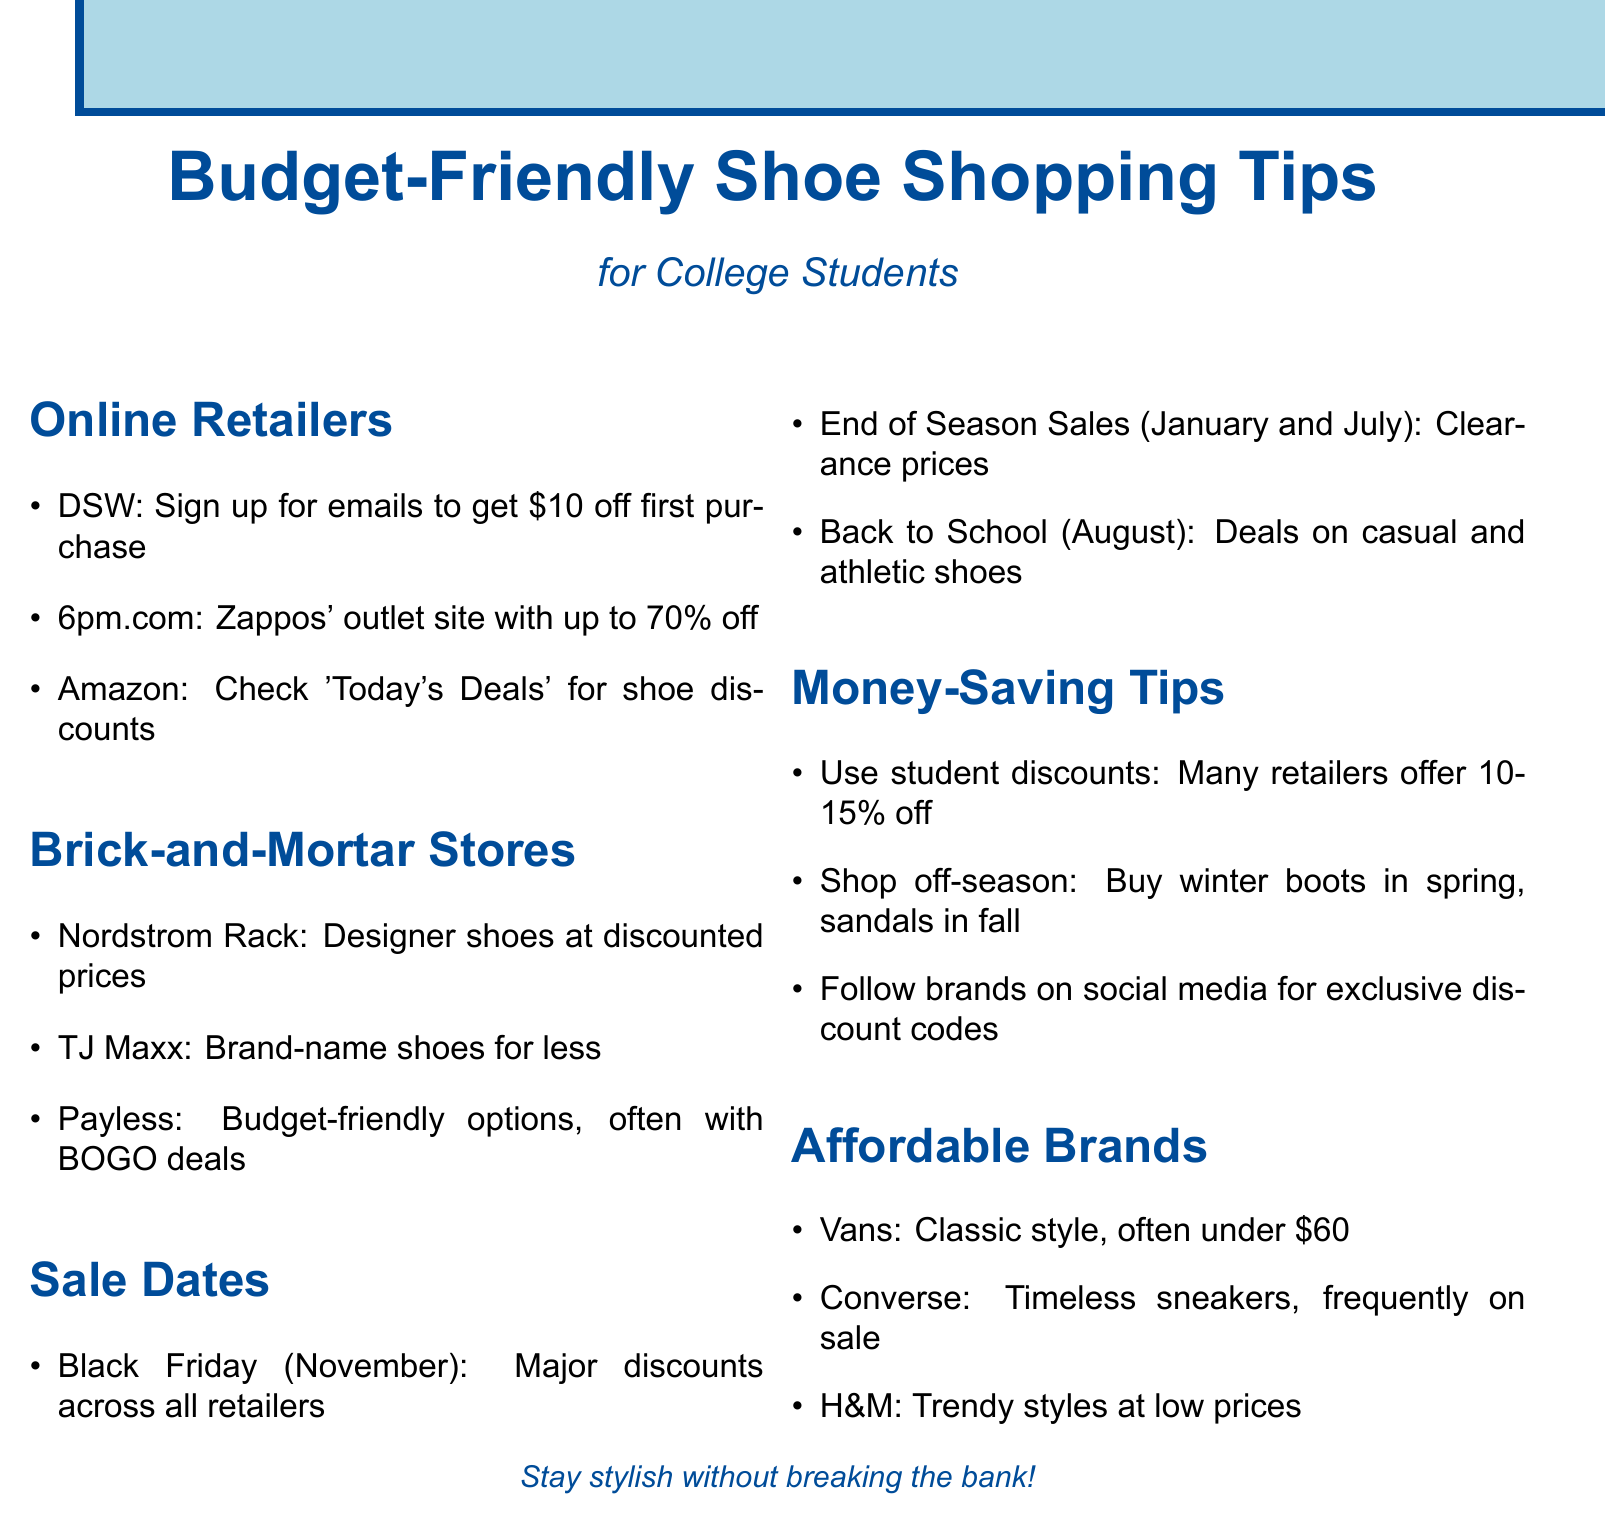What is the title of the document? The title of the document is stated at the top and summarizes the content.
Answer: Budget-Friendly Shoe Shopping Tips for College Students Which retailer offers up to 70% off? This information is found under the Online Retailers section and highlights a discount site.
Answer: 6pm.com When is Black Friday? The date of Black Friday is mentioned in the Sale Dates section as a specific month.
Answer: November What is one of the money-saving tips mentioned? The tip comes from the Money-Saving Tips section of the document.
Answer: Use student discounts Which brand is known for classic shoes under $60? This information is found under the Affordable Brands section, which lists budget-friendly brands.
Answer: Vans How often are end-of-season sales held? The document states the months when these sales occur in the Sale Dates section.
Answer: January and July What type of shoes can be found during Back to School sales? This question refers to deals on specific categories of shoes mentioned in the Sale Dates section.
Answer: Casual and athletic shoes 